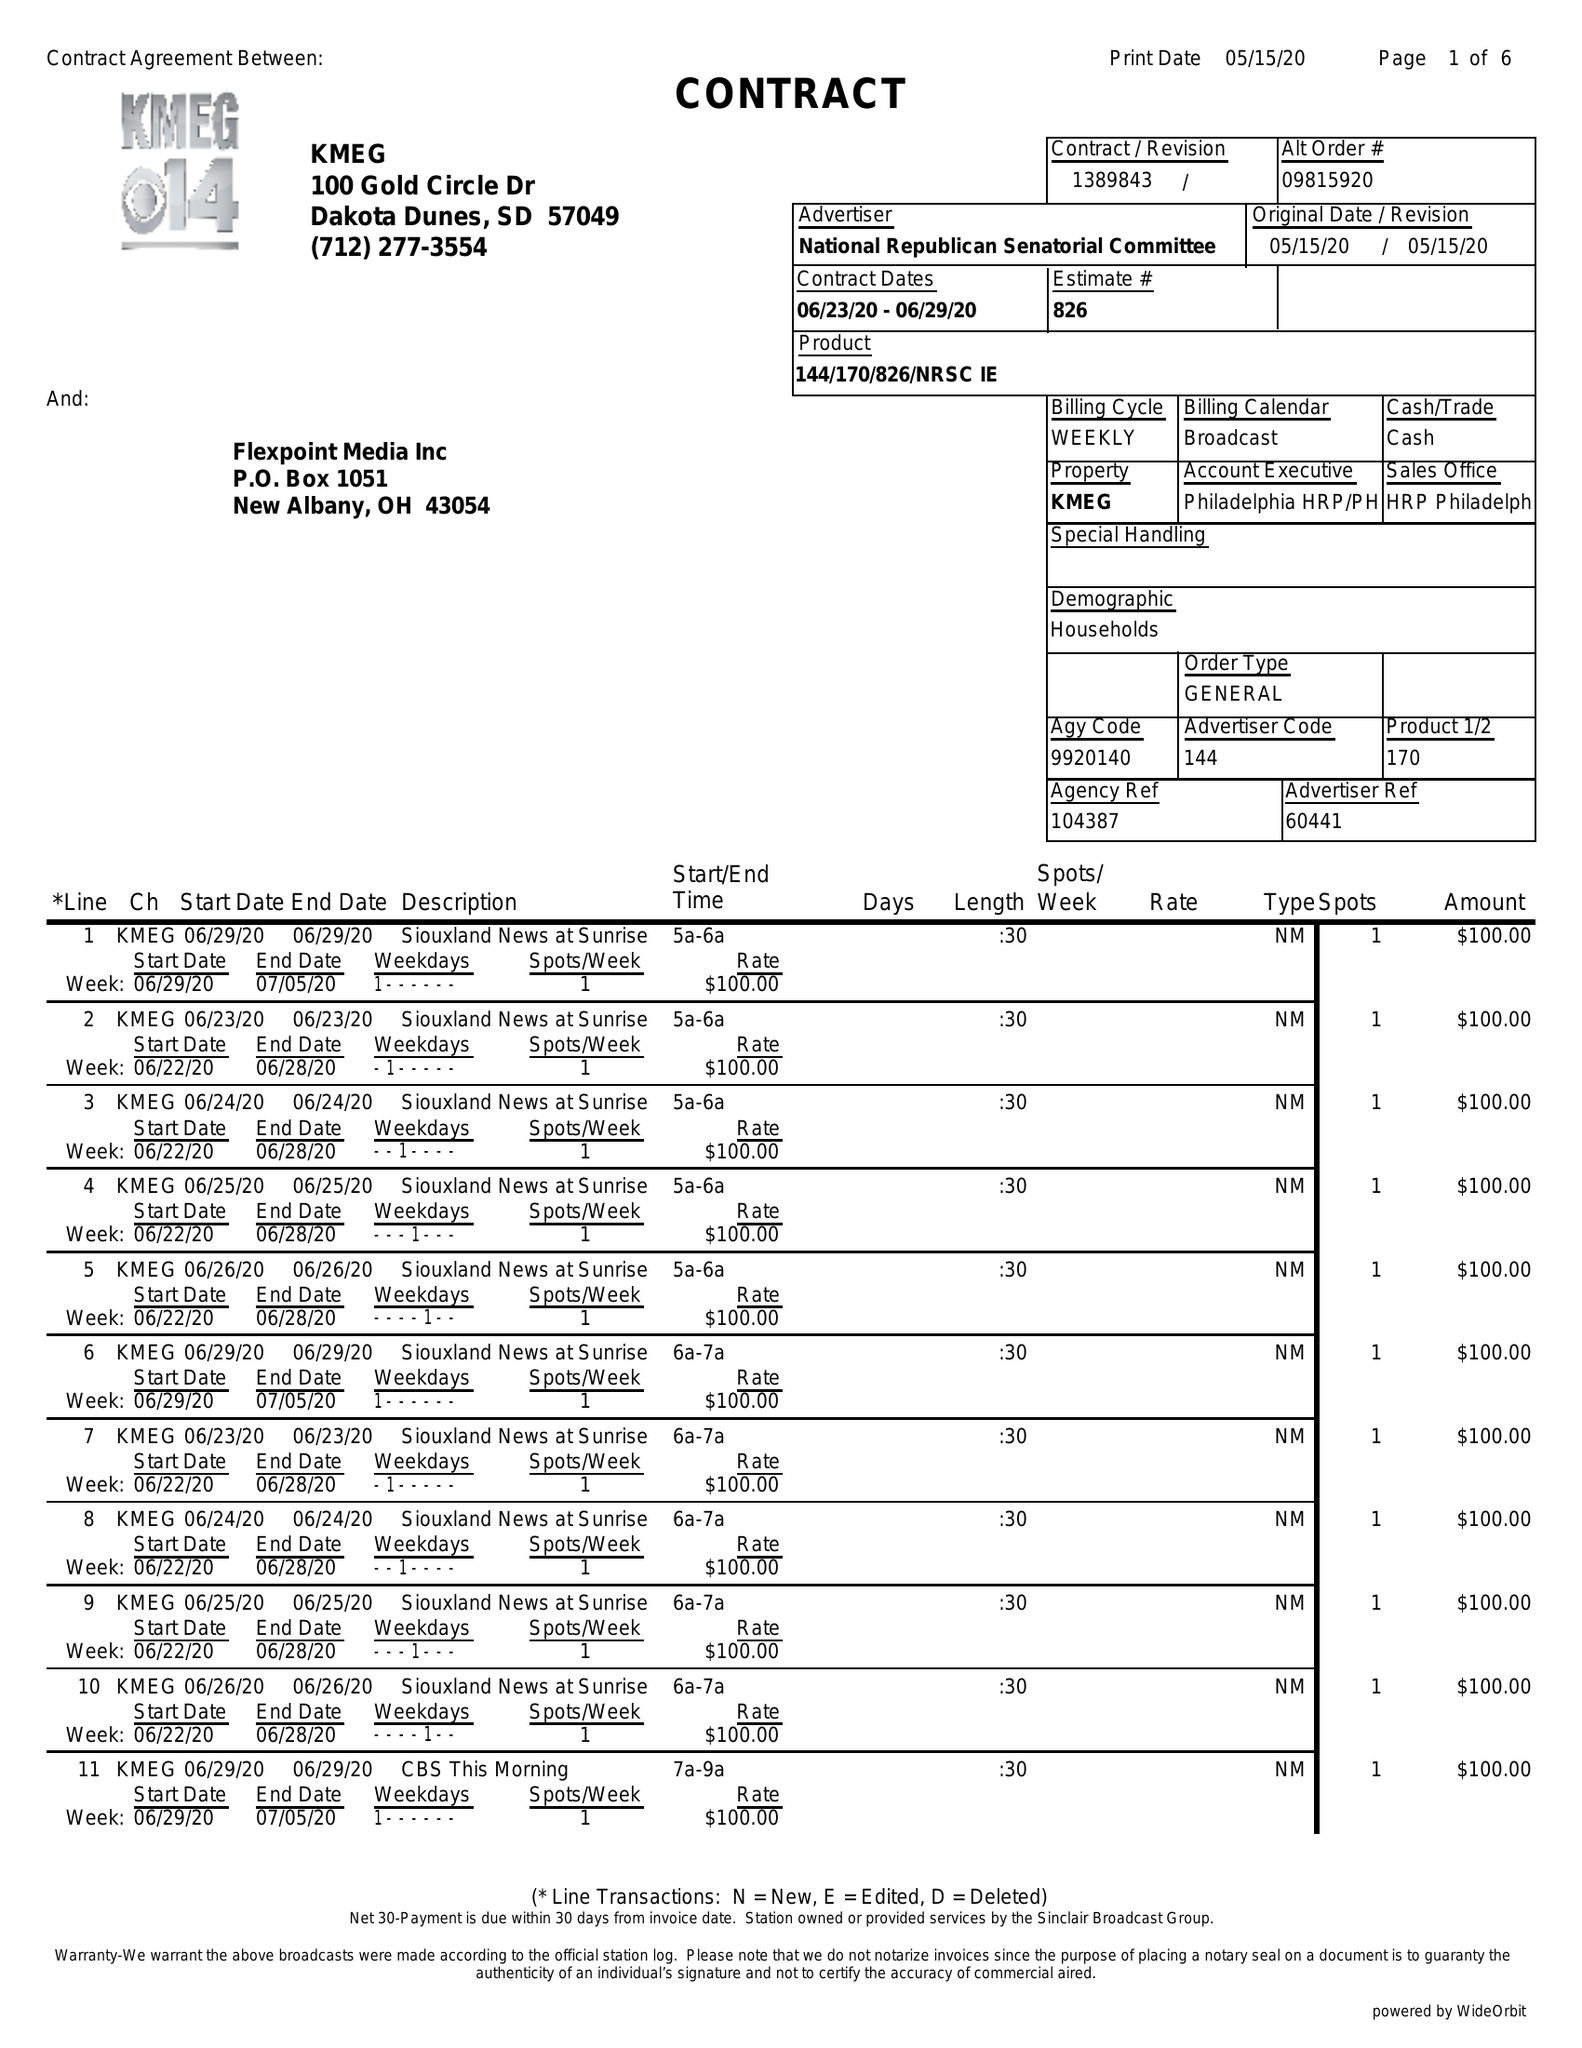What is the value for the gross_amount?
Answer the question using a single word or phrase. 31450.00 